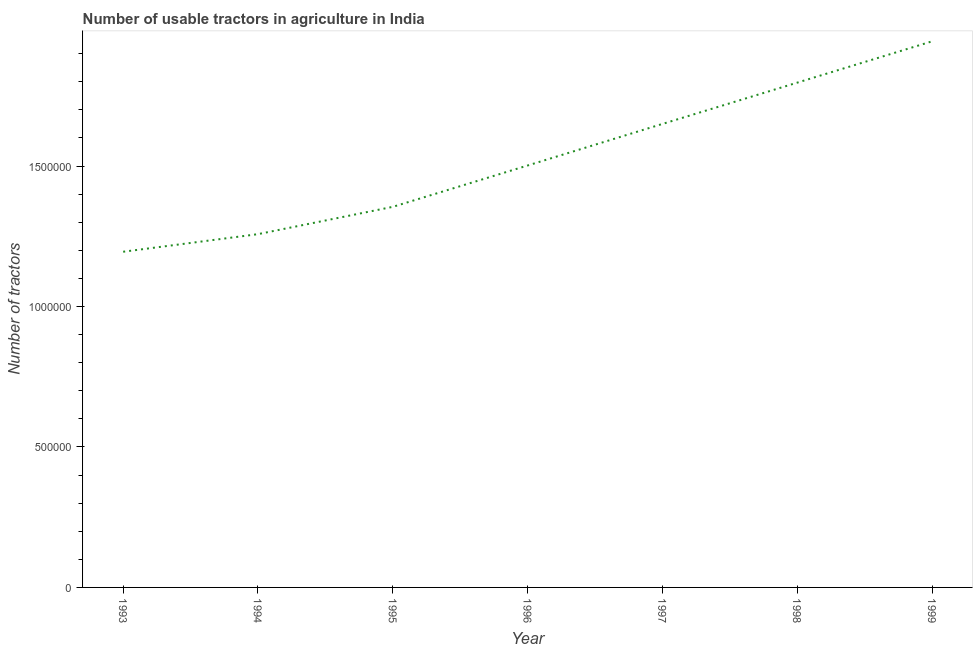What is the number of tractors in 1999?
Your answer should be very brief. 1.94e+06. Across all years, what is the maximum number of tractors?
Your answer should be very brief. 1.94e+06. Across all years, what is the minimum number of tractors?
Give a very brief answer. 1.20e+06. In which year was the number of tractors minimum?
Ensure brevity in your answer.  1993. What is the sum of the number of tractors?
Keep it short and to the point. 1.07e+07. What is the difference between the number of tractors in 1994 and 1996?
Make the answer very short. -2.44e+05. What is the average number of tractors per year?
Offer a terse response. 1.53e+06. What is the median number of tractors?
Your answer should be very brief. 1.50e+06. Do a majority of the years between 1995 and 1996 (inclusive) have number of tractors greater than 1200000 ?
Give a very brief answer. Yes. What is the ratio of the number of tractors in 1994 to that in 1997?
Provide a succinct answer. 0.76. Is the number of tractors in 1994 less than that in 1999?
Offer a terse response. Yes. What is the difference between the highest and the second highest number of tractors?
Your answer should be very brief. 1.47e+05. Is the sum of the number of tractors in 1993 and 1995 greater than the maximum number of tractors across all years?
Your response must be concise. Yes. What is the difference between the highest and the lowest number of tractors?
Your response must be concise. 7.49e+05. Does the number of tractors monotonically increase over the years?
Keep it short and to the point. Yes. How many years are there in the graph?
Give a very brief answer. 7. Does the graph contain any zero values?
Your answer should be compact. No. Does the graph contain grids?
Your answer should be compact. No. What is the title of the graph?
Give a very brief answer. Number of usable tractors in agriculture in India. What is the label or title of the Y-axis?
Give a very brief answer. Number of tractors. What is the Number of tractors in 1993?
Ensure brevity in your answer.  1.20e+06. What is the Number of tractors of 1994?
Your response must be concise. 1.26e+06. What is the Number of tractors in 1995?
Your answer should be very brief. 1.35e+06. What is the Number of tractors in 1996?
Your response must be concise. 1.50e+06. What is the Number of tractors in 1997?
Provide a short and direct response. 1.65e+06. What is the Number of tractors of 1998?
Ensure brevity in your answer.  1.80e+06. What is the Number of tractors in 1999?
Your answer should be compact. 1.94e+06. What is the difference between the Number of tractors in 1993 and 1994?
Provide a short and direct response. -6.26e+04. What is the difference between the Number of tractors in 1993 and 1995?
Provide a short and direct response. -1.60e+05. What is the difference between the Number of tractors in 1993 and 1996?
Keep it short and to the point. -3.07e+05. What is the difference between the Number of tractors in 1993 and 1997?
Keep it short and to the point. -4.55e+05. What is the difference between the Number of tractors in 1993 and 1998?
Provide a short and direct response. -6.02e+05. What is the difference between the Number of tractors in 1993 and 1999?
Your answer should be compact. -7.49e+05. What is the difference between the Number of tractors in 1994 and 1995?
Offer a very short reply. -9.72e+04. What is the difference between the Number of tractors in 1994 and 1996?
Your answer should be very brief. -2.44e+05. What is the difference between the Number of tractors in 1994 and 1997?
Provide a short and direct response. -3.92e+05. What is the difference between the Number of tractors in 1994 and 1998?
Your answer should be compact. -5.39e+05. What is the difference between the Number of tractors in 1994 and 1999?
Offer a terse response. -6.86e+05. What is the difference between the Number of tractors in 1995 and 1996?
Provide a succinct answer. -1.47e+05. What is the difference between the Number of tractors in 1995 and 1997?
Your answer should be compact. -2.95e+05. What is the difference between the Number of tractors in 1995 and 1998?
Offer a very short reply. -4.42e+05. What is the difference between the Number of tractors in 1995 and 1999?
Keep it short and to the point. -5.89e+05. What is the difference between the Number of tractors in 1996 and 1997?
Provide a succinct answer. -1.48e+05. What is the difference between the Number of tractors in 1996 and 1998?
Your answer should be very brief. -2.95e+05. What is the difference between the Number of tractors in 1996 and 1999?
Provide a succinct answer. -4.42e+05. What is the difference between the Number of tractors in 1997 and 1998?
Your answer should be compact. -1.47e+05. What is the difference between the Number of tractors in 1997 and 1999?
Offer a very short reply. -2.94e+05. What is the difference between the Number of tractors in 1998 and 1999?
Ensure brevity in your answer.  -1.47e+05. What is the ratio of the Number of tractors in 1993 to that in 1994?
Provide a succinct answer. 0.95. What is the ratio of the Number of tractors in 1993 to that in 1995?
Offer a terse response. 0.88. What is the ratio of the Number of tractors in 1993 to that in 1996?
Your answer should be compact. 0.8. What is the ratio of the Number of tractors in 1993 to that in 1997?
Offer a very short reply. 0.72. What is the ratio of the Number of tractors in 1993 to that in 1998?
Give a very brief answer. 0.67. What is the ratio of the Number of tractors in 1993 to that in 1999?
Your response must be concise. 0.61. What is the ratio of the Number of tractors in 1994 to that in 1995?
Provide a succinct answer. 0.93. What is the ratio of the Number of tractors in 1994 to that in 1996?
Offer a terse response. 0.84. What is the ratio of the Number of tractors in 1994 to that in 1997?
Give a very brief answer. 0.76. What is the ratio of the Number of tractors in 1994 to that in 1999?
Provide a short and direct response. 0.65. What is the ratio of the Number of tractors in 1995 to that in 1996?
Your answer should be compact. 0.9. What is the ratio of the Number of tractors in 1995 to that in 1997?
Give a very brief answer. 0.82. What is the ratio of the Number of tractors in 1995 to that in 1998?
Offer a very short reply. 0.75. What is the ratio of the Number of tractors in 1995 to that in 1999?
Offer a very short reply. 0.7. What is the ratio of the Number of tractors in 1996 to that in 1997?
Offer a very short reply. 0.91. What is the ratio of the Number of tractors in 1996 to that in 1998?
Your response must be concise. 0.84. What is the ratio of the Number of tractors in 1996 to that in 1999?
Ensure brevity in your answer.  0.77. What is the ratio of the Number of tractors in 1997 to that in 1998?
Provide a short and direct response. 0.92. What is the ratio of the Number of tractors in 1997 to that in 1999?
Ensure brevity in your answer.  0.85. What is the ratio of the Number of tractors in 1998 to that in 1999?
Provide a short and direct response. 0.92. 